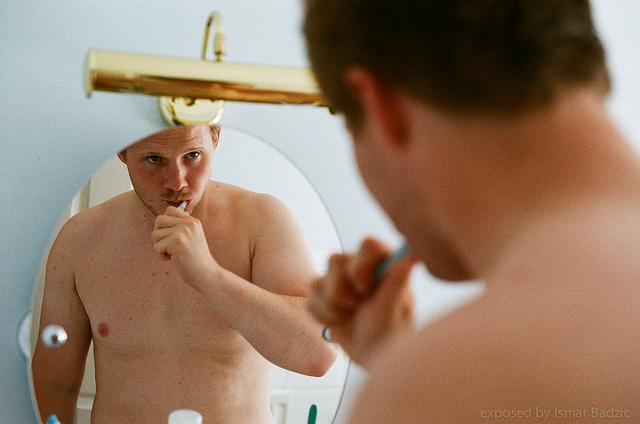What is this activity good for? Please explain your reasoning. gum health. Brushing teeth keeps the skin next to the teeth healthy and clean. 